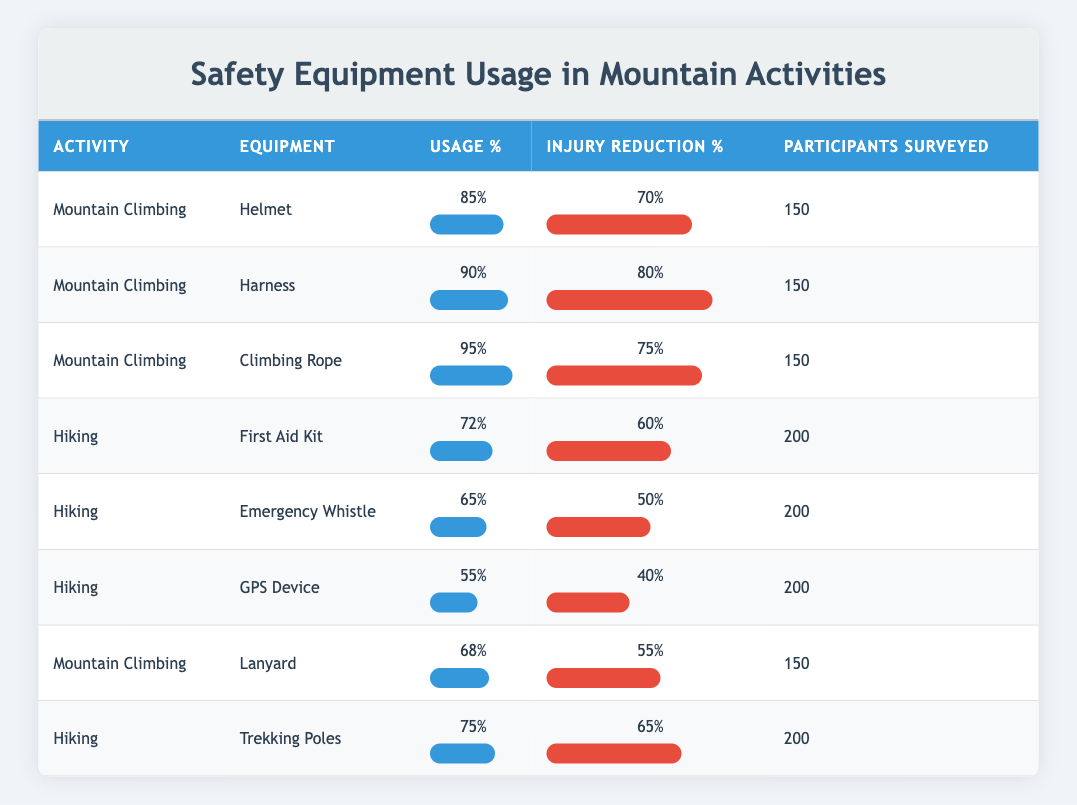What is the usage percentage of helmets in mountain climbing? The table lists the safety equipment used in mountain climbing, and the row corresponding to the helmet shows a usage percentage of 85%.
Answer: 85% What is the injury reduction percentage for trekking poles in hiking? According to the table, the injury reduction percentage for trekking poles, which is listed under hiking, is 65%.
Answer: 65% Is the usage percentage of emergency whistles higher than that of GPS devices in hiking? The table reveals that the usage percentage for emergency whistles is 65%, while for GPS devices, it is 55%. Since 65% is greater than 55%, the statement is true.
Answer: Yes What safety equipment in mountain climbing has the highest injury reduction percentage? By examining the injury reduction percentages listed for mountain climbing, helmet has 70%, harness has 80%, climbing rope has 75%, and lanyard has 55%. The harness has the highest reduction percentage at 80%.
Answer: Harness What is the average usage percentage of safety equipment used in hiking? The usage percentages for hiking are 72%, 65%, 55%, and 75%. To find the average, sum these percentages (72 + 65 + 55 + 75 = 267) and divide by the number of equipment (4), resulting in an average of 267/4 = 66.75%.
Answer: 66.75% Is the injury reduction percentage for climbing rope greater than that for first aid kits? From the table, climbing rope has an injury reduction percentage of 75%, while first aid kit has 60%. Since 75% is greater than 60%, the statement is true.
Answer: Yes What is the total number of participants surveyed for hiking safety equipment? The table indicates that for hiking, the number of participants surveyed is consistently 200 across all equipment listed. Therefore, it remains the same at 200.
Answer: 200 Which safety equipment used in mountain climbing has a usage percentage lower than 90%? The equipment used in mountain climbing with a usage percentage lower than 90% is the lanyard, which has a usage percentage of 68%.
Answer: Lanyard What is the difference in injury reduction percentage between harness and first aid kit? The harness has an injury reduction percentage of 80%, and the first aid kit's percentage is 60%. The difference is calculated as 80 - 60 = 20%.
Answer: 20% 